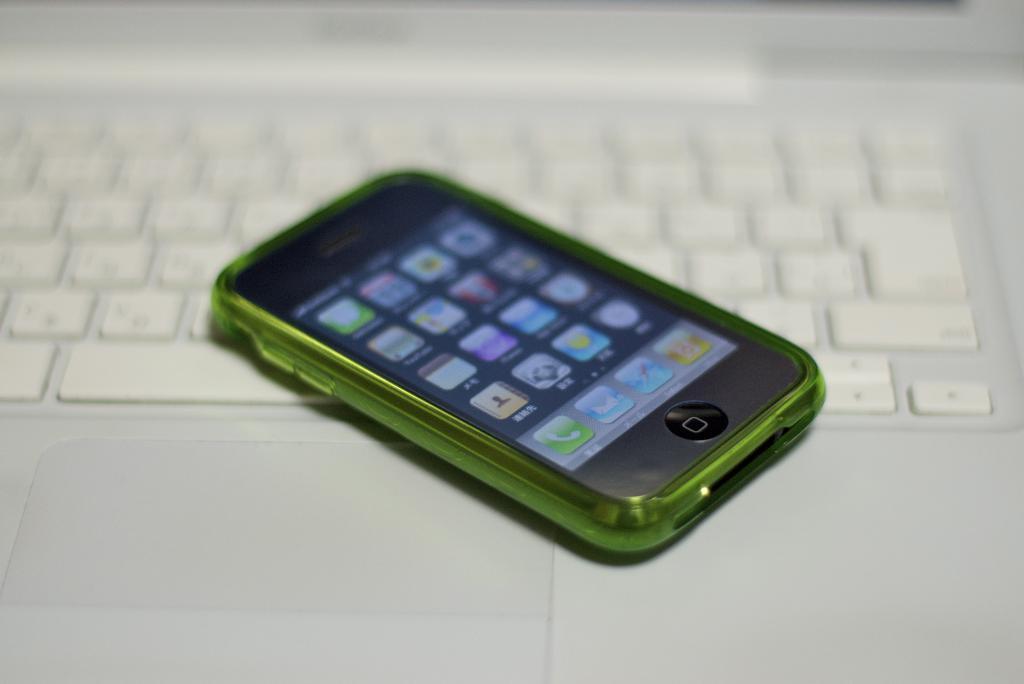How would you summarize this image in a sentence or two? In this picture i can see a mobile on a white color keyboard. On the mobile screen i can see icons. 